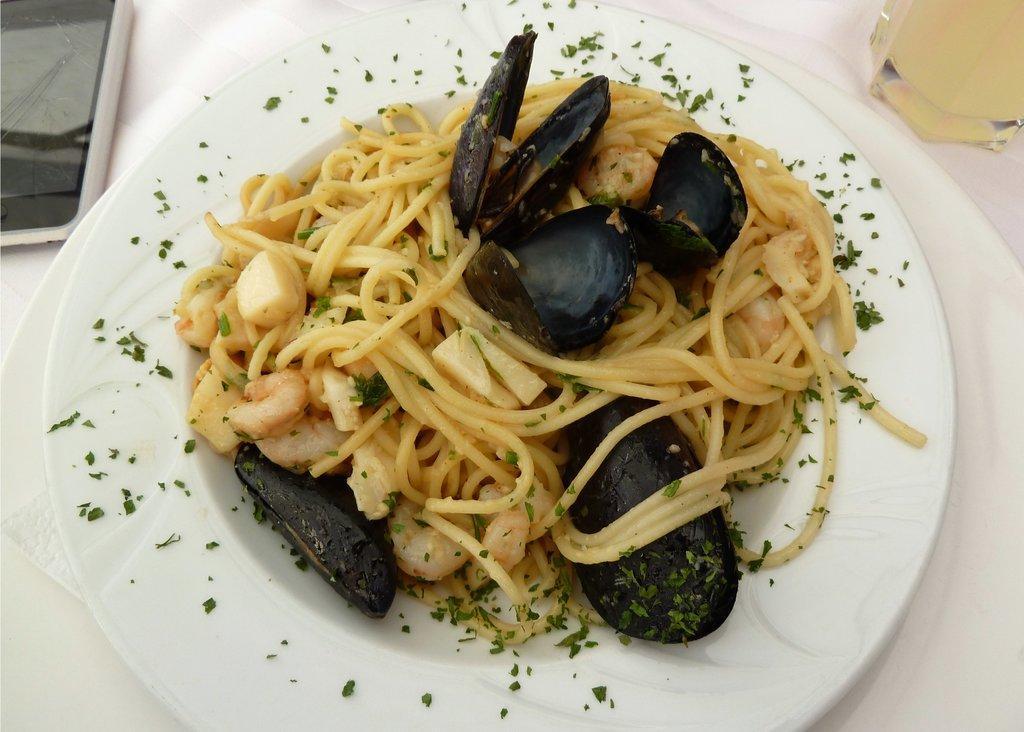Could you give a brief overview of what you see in this image? Here I can see a table which is covered with a white color cloth. On the table there is a plate which consists of some food, a mobile and a glass. 